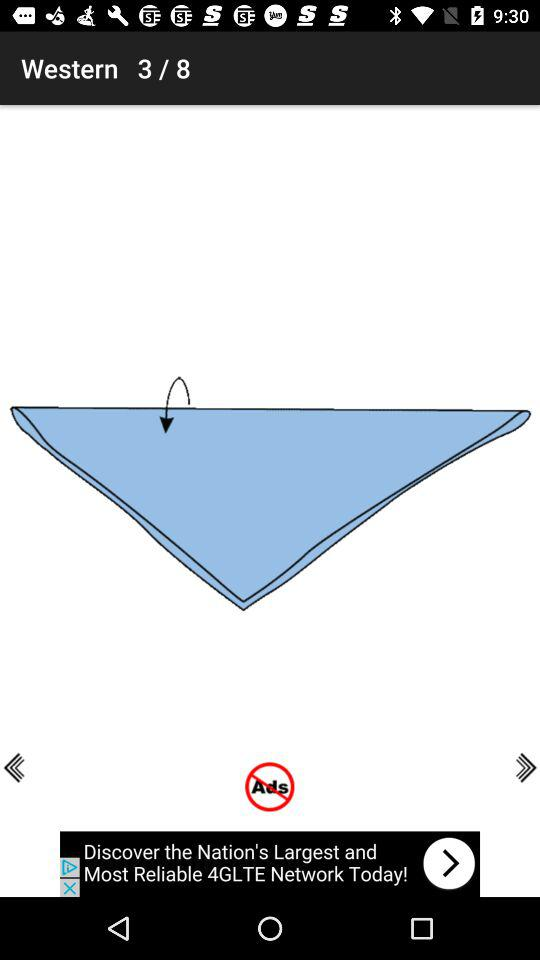How many pages are there? There are 8 pages. 